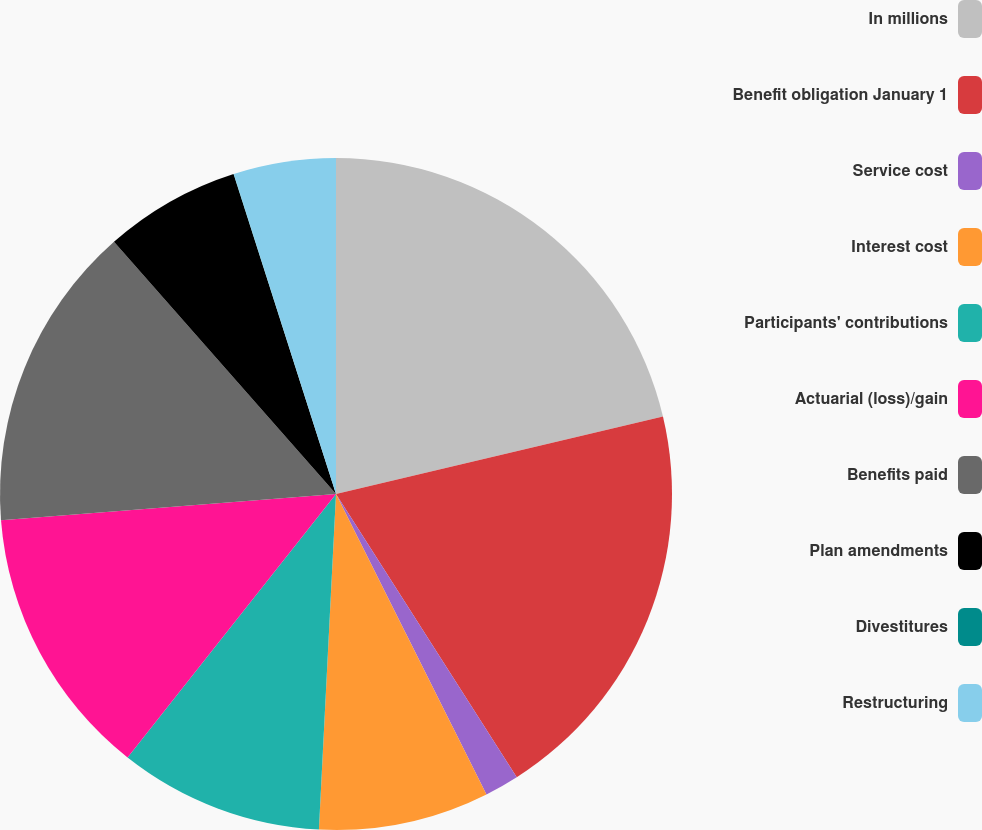<chart> <loc_0><loc_0><loc_500><loc_500><pie_chart><fcel>In millions<fcel>Benefit obligation January 1<fcel>Service cost<fcel>Interest cost<fcel>Participants' contributions<fcel>Actuarial (loss)/gain<fcel>Benefits paid<fcel>Plan amendments<fcel>Divestitures<fcel>Restructuring<nl><fcel>21.3%<fcel>19.66%<fcel>1.65%<fcel>8.2%<fcel>9.84%<fcel>13.11%<fcel>14.75%<fcel>6.56%<fcel>0.01%<fcel>4.92%<nl></chart> 